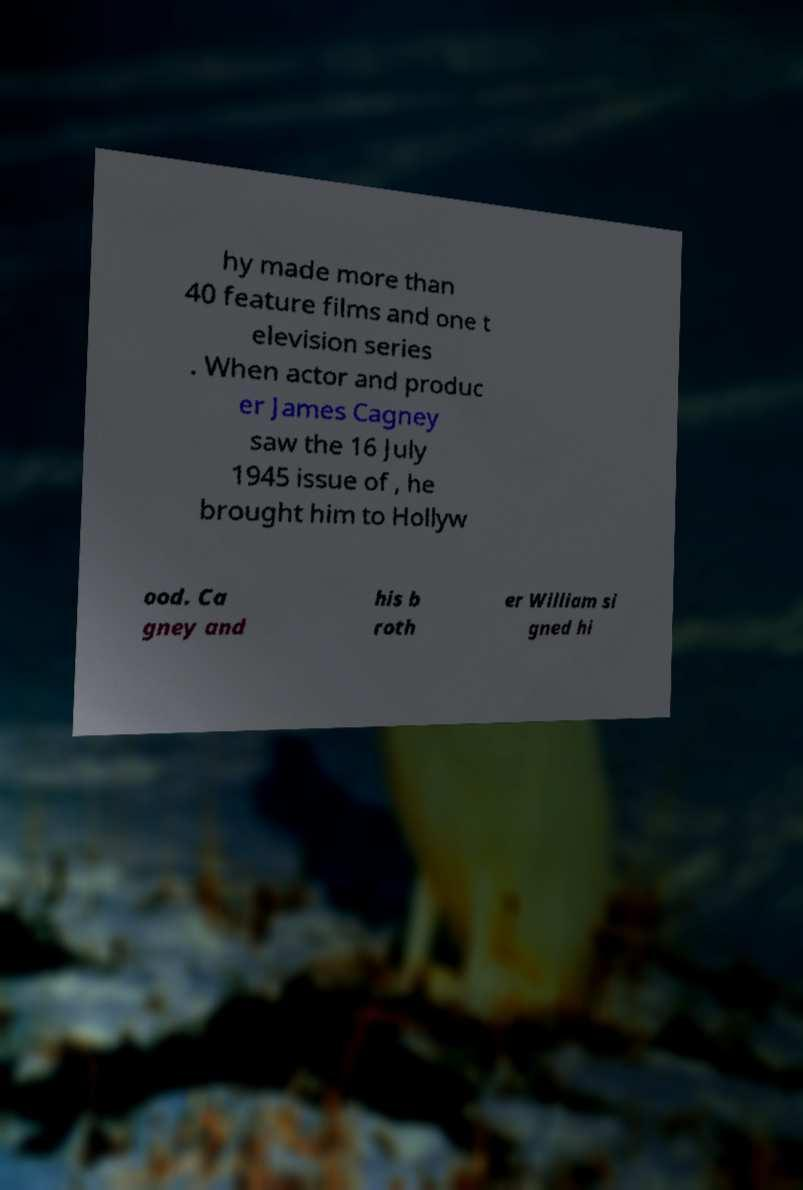Could you extract and type out the text from this image? hy made more than 40 feature films and one t elevision series . When actor and produc er James Cagney saw the 16 July 1945 issue of , he brought him to Hollyw ood. Ca gney and his b roth er William si gned hi 